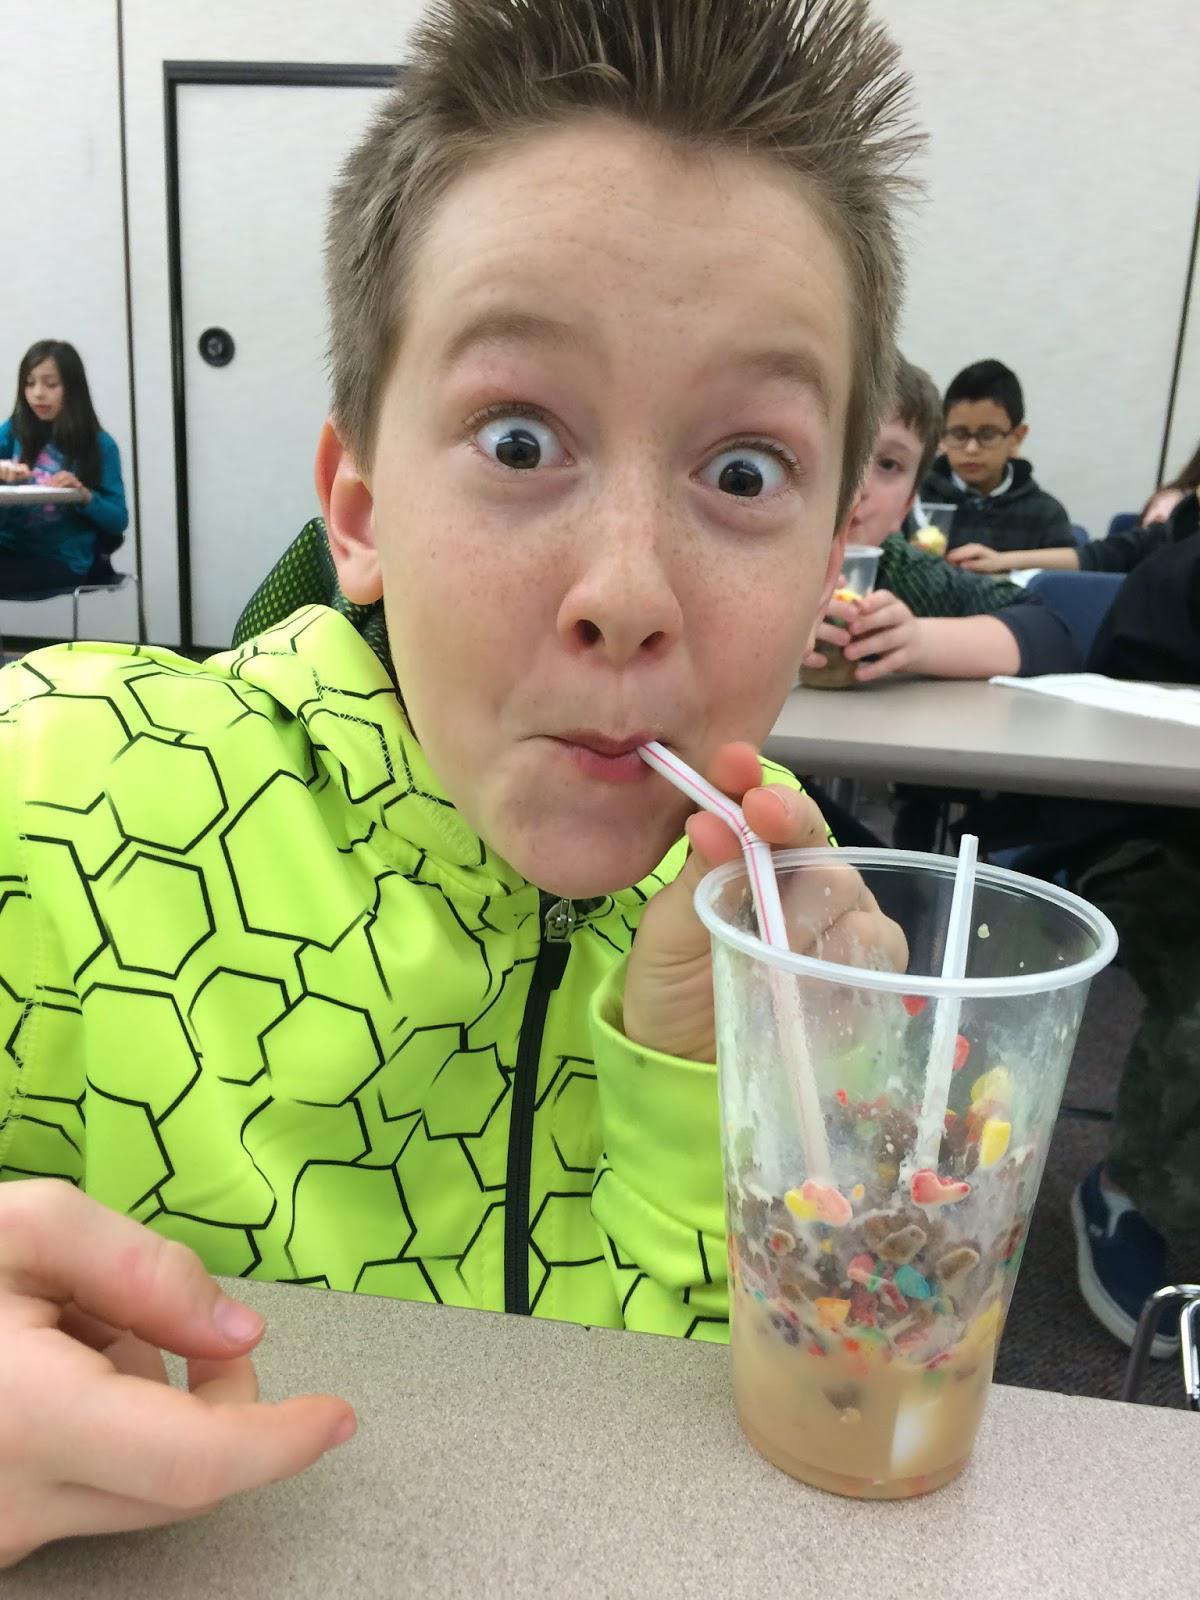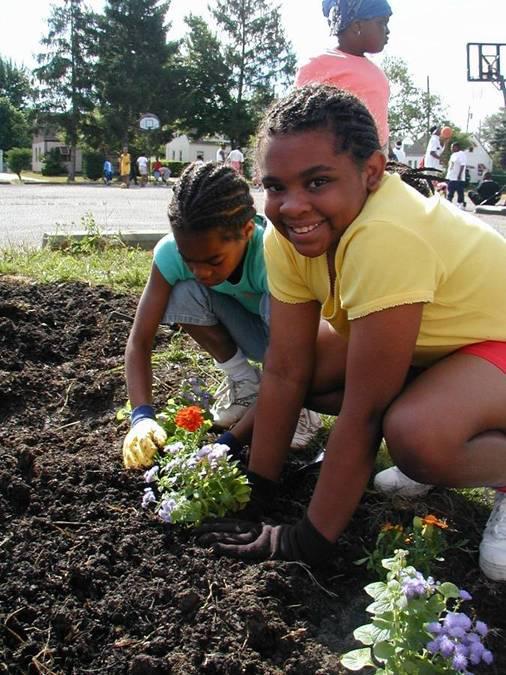The first image is the image on the left, the second image is the image on the right. Examine the images to the left and right. Is the description "In one image a boy in a uniform is holding up a green plant in front of him with both hands." accurate? Answer yes or no. No. The first image is the image on the left, the second image is the image on the right. Examine the images to the left and right. Is the description "One person is holding a plant." accurate? Answer yes or no. No. 